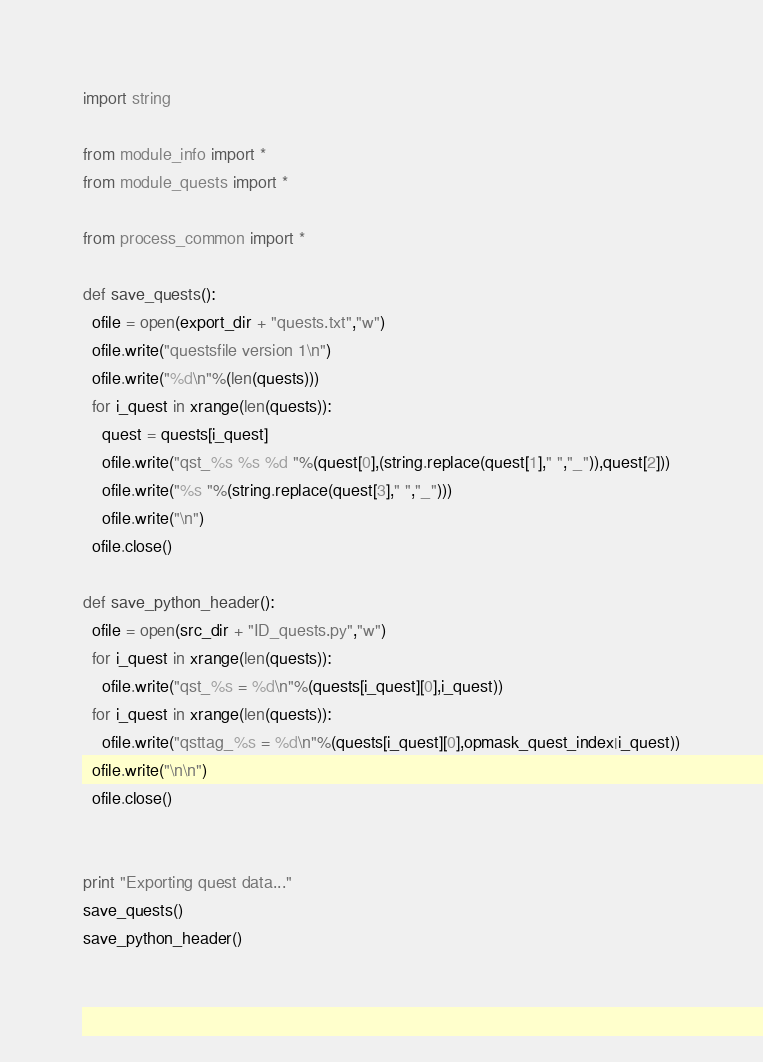Convert code to text. <code><loc_0><loc_0><loc_500><loc_500><_Python_>import string

from module_info import *
from module_quests import *

from process_common import *

def save_quests():
  ofile = open(export_dir + "quests.txt","w")
  ofile.write("questsfile version 1\n")
  ofile.write("%d\n"%(len(quests)))
  for i_quest in xrange(len(quests)):
    quest = quests[i_quest]
    ofile.write("qst_%s %s %d "%(quest[0],(string.replace(quest[1]," ","_")),quest[2]))
    ofile.write("%s "%(string.replace(quest[3]," ","_")))
    ofile.write("\n")
  ofile.close()

def save_python_header():
  ofile = open(src_dir + "ID_quests.py","w")
  for i_quest in xrange(len(quests)):
    ofile.write("qst_%s = %d\n"%(quests[i_quest][0],i_quest))
  for i_quest in xrange(len(quests)):
    ofile.write("qsttag_%s = %d\n"%(quests[i_quest][0],opmask_quest_index|i_quest))
  ofile.write("\n\n")
  ofile.close()


print "Exporting quest data..."
save_quests()
save_python_header()
  
</code> 